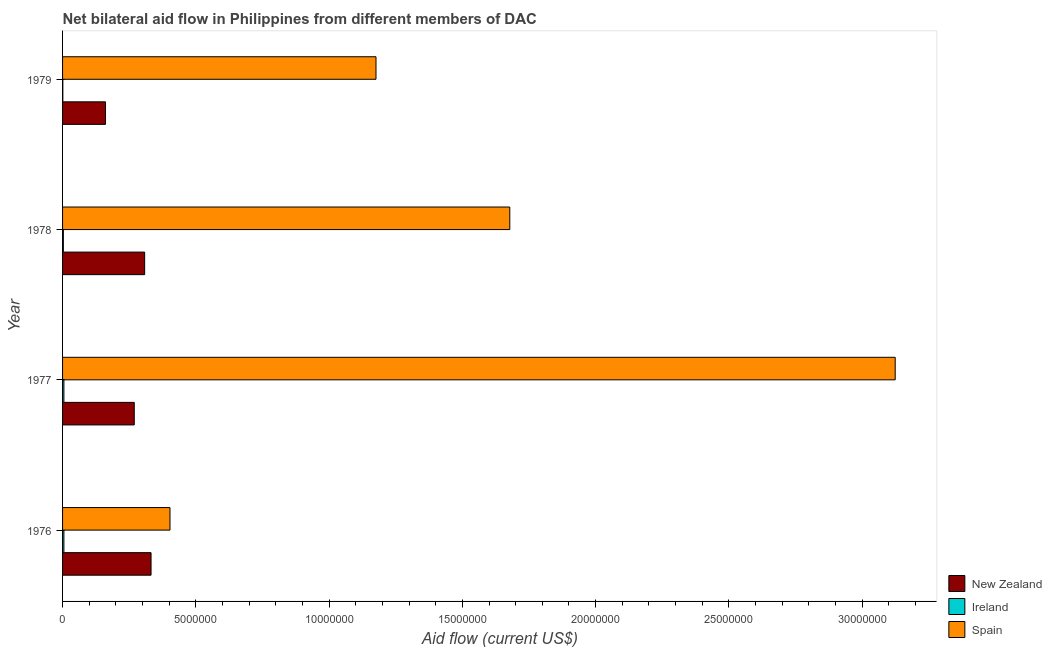How many different coloured bars are there?
Keep it short and to the point. 3. How many groups of bars are there?
Your response must be concise. 4. Are the number of bars per tick equal to the number of legend labels?
Ensure brevity in your answer.  Yes. Are the number of bars on each tick of the Y-axis equal?
Ensure brevity in your answer.  Yes. How many bars are there on the 1st tick from the top?
Make the answer very short. 3. How many bars are there on the 1st tick from the bottom?
Ensure brevity in your answer.  3. What is the label of the 4th group of bars from the top?
Give a very brief answer. 1976. What is the amount of aid provided by spain in 1978?
Keep it short and to the point. 1.68e+07. Across all years, what is the maximum amount of aid provided by spain?
Your response must be concise. 3.12e+07. Across all years, what is the minimum amount of aid provided by spain?
Your answer should be compact. 4.03e+06. In which year was the amount of aid provided by ireland maximum?
Ensure brevity in your answer.  1976. In which year was the amount of aid provided by spain minimum?
Offer a very short reply. 1976. What is the total amount of aid provided by spain in the graph?
Make the answer very short. 6.38e+07. What is the difference between the amount of aid provided by ireland in 1977 and that in 1979?
Give a very brief answer. 4.00e+04. What is the difference between the amount of aid provided by ireland in 1978 and the amount of aid provided by new zealand in 1977?
Offer a very short reply. -2.66e+06. What is the average amount of aid provided by new zealand per year?
Ensure brevity in your answer.  2.68e+06. In the year 1976, what is the difference between the amount of aid provided by spain and amount of aid provided by new zealand?
Provide a succinct answer. 7.10e+05. What is the ratio of the amount of aid provided by spain in 1978 to that in 1979?
Offer a very short reply. 1.43. Is the amount of aid provided by spain in 1976 less than that in 1979?
Provide a short and direct response. Yes. Is the difference between the amount of aid provided by ireland in 1976 and 1977 greater than the difference between the amount of aid provided by spain in 1976 and 1977?
Your answer should be compact. Yes. What is the difference between the highest and the second highest amount of aid provided by new zealand?
Provide a succinct answer. 2.40e+05. What is the difference between the highest and the lowest amount of aid provided by spain?
Make the answer very short. 2.72e+07. Is the sum of the amount of aid provided by spain in 1976 and 1978 greater than the maximum amount of aid provided by new zealand across all years?
Your response must be concise. Yes. What does the 2nd bar from the top in 1978 represents?
Offer a terse response. Ireland. What does the 1st bar from the bottom in 1978 represents?
Make the answer very short. New Zealand. How many bars are there?
Offer a terse response. 12. Are the values on the major ticks of X-axis written in scientific E-notation?
Your answer should be compact. No. Does the graph contain any zero values?
Keep it short and to the point. No. Does the graph contain grids?
Your response must be concise. No. How many legend labels are there?
Provide a succinct answer. 3. What is the title of the graph?
Your response must be concise. Net bilateral aid flow in Philippines from different members of DAC. Does "Czech Republic" appear as one of the legend labels in the graph?
Keep it short and to the point. No. What is the label or title of the Y-axis?
Make the answer very short. Year. What is the Aid flow (current US$) of New Zealand in 1976?
Your answer should be very brief. 3.32e+06. What is the Aid flow (current US$) of Ireland in 1976?
Make the answer very short. 5.00e+04. What is the Aid flow (current US$) of Spain in 1976?
Provide a short and direct response. 4.03e+06. What is the Aid flow (current US$) in New Zealand in 1977?
Offer a very short reply. 2.69e+06. What is the Aid flow (current US$) in Spain in 1977?
Provide a succinct answer. 3.12e+07. What is the Aid flow (current US$) of New Zealand in 1978?
Your response must be concise. 3.08e+06. What is the Aid flow (current US$) in Ireland in 1978?
Give a very brief answer. 3.00e+04. What is the Aid flow (current US$) in Spain in 1978?
Ensure brevity in your answer.  1.68e+07. What is the Aid flow (current US$) in New Zealand in 1979?
Your answer should be very brief. 1.61e+06. What is the Aid flow (current US$) of Spain in 1979?
Your answer should be compact. 1.18e+07. Across all years, what is the maximum Aid flow (current US$) in New Zealand?
Provide a succinct answer. 3.32e+06. Across all years, what is the maximum Aid flow (current US$) in Ireland?
Provide a succinct answer. 5.00e+04. Across all years, what is the maximum Aid flow (current US$) of Spain?
Give a very brief answer. 3.12e+07. Across all years, what is the minimum Aid flow (current US$) of New Zealand?
Your answer should be compact. 1.61e+06. Across all years, what is the minimum Aid flow (current US$) of Ireland?
Your response must be concise. 10000. Across all years, what is the minimum Aid flow (current US$) in Spain?
Ensure brevity in your answer.  4.03e+06. What is the total Aid flow (current US$) of New Zealand in the graph?
Offer a terse response. 1.07e+07. What is the total Aid flow (current US$) of Spain in the graph?
Keep it short and to the point. 6.38e+07. What is the difference between the Aid flow (current US$) of New Zealand in 1976 and that in 1977?
Your answer should be very brief. 6.30e+05. What is the difference between the Aid flow (current US$) in Ireland in 1976 and that in 1977?
Ensure brevity in your answer.  0. What is the difference between the Aid flow (current US$) in Spain in 1976 and that in 1977?
Your answer should be compact. -2.72e+07. What is the difference between the Aid flow (current US$) of New Zealand in 1976 and that in 1978?
Keep it short and to the point. 2.40e+05. What is the difference between the Aid flow (current US$) of Spain in 1976 and that in 1978?
Offer a very short reply. -1.28e+07. What is the difference between the Aid flow (current US$) of New Zealand in 1976 and that in 1979?
Provide a succinct answer. 1.71e+06. What is the difference between the Aid flow (current US$) of Ireland in 1976 and that in 1979?
Keep it short and to the point. 4.00e+04. What is the difference between the Aid flow (current US$) in Spain in 1976 and that in 1979?
Your answer should be very brief. -7.73e+06. What is the difference between the Aid flow (current US$) of New Zealand in 1977 and that in 1978?
Your answer should be compact. -3.90e+05. What is the difference between the Aid flow (current US$) in Ireland in 1977 and that in 1978?
Give a very brief answer. 2.00e+04. What is the difference between the Aid flow (current US$) in Spain in 1977 and that in 1978?
Keep it short and to the point. 1.45e+07. What is the difference between the Aid flow (current US$) in New Zealand in 1977 and that in 1979?
Provide a succinct answer. 1.08e+06. What is the difference between the Aid flow (current US$) of Spain in 1977 and that in 1979?
Provide a succinct answer. 1.95e+07. What is the difference between the Aid flow (current US$) of New Zealand in 1978 and that in 1979?
Your answer should be compact. 1.47e+06. What is the difference between the Aid flow (current US$) in Ireland in 1978 and that in 1979?
Offer a terse response. 2.00e+04. What is the difference between the Aid flow (current US$) of Spain in 1978 and that in 1979?
Offer a very short reply. 5.02e+06. What is the difference between the Aid flow (current US$) in New Zealand in 1976 and the Aid flow (current US$) in Ireland in 1977?
Keep it short and to the point. 3.27e+06. What is the difference between the Aid flow (current US$) of New Zealand in 1976 and the Aid flow (current US$) of Spain in 1977?
Make the answer very short. -2.79e+07. What is the difference between the Aid flow (current US$) in Ireland in 1976 and the Aid flow (current US$) in Spain in 1977?
Make the answer very short. -3.12e+07. What is the difference between the Aid flow (current US$) in New Zealand in 1976 and the Aid flow (current US$) in Ireland in 1978?
Provide a short and direct response. 3.29e+06. What is the difference between the Aid flow (current US$) in New Zealand in 1976 and the Aid flow (current US$) in Spain in 1978?
Offer a terse response. -1.35e+07. What is the difference between the Aid flow (current US$) in Ireland in 1976 and the Aid flow (current US$) in Spain in 1978?
Your answer should be very brief. -1.67e+07. What is the difference between the Aid flow (current US$) in New Zealand in 1976 and the Aid flow (current US$) in Ireland in 1979?
Keep it short and to the point. 3.31e+06. What is the difference between the Aid flow (current US$) of New Zealand in 1976 and the Aid flow (current US$) of Spain in 1979?
Your response must be concise. -8.44e+06. What is the difference between the Aid flow (current US$) of Ireland in 1976 and the Aid flow (current US$) of Spain in 1979?
Your answer should be very brief. -1.17e+07. What is the difference between the Aid flow (current US$) of New Zealand in 1977 and the Aid flow (current US$) of Ireland in 1978?
Your answer should be very brief. 2.66e+06. What is the difference between the Aid flow (current US$) in New Zealand in 1977 and the Aid flow (current US$) in Spain in 1978?
Keep it short and to the point. -1.41e+07. What is the difference between the Aid flow (current US$) in Ireland in 1977 and the Aid flow (current US$) in Spain in 1978?
Offer a very short reply. -1.67e+07. What is the difference between the Aid flow (current US$) of New Zealand in 1977 and the Aid flow (current US$) of Ireland in 1979?
Ensure brevity in your answer.  2.68e+06. What is the difference between the Aid flow (current US$) of New Zealand in 1977 and the Aid flow (current US$) of Spain in 1979?
Your answer should be compact. -9.07e+06. What is the difference between the Aid flow (current US$) of Ireland in 1977 and the Aid flow (current US$) of Spain in 1979?
Provide a short and direct response. -1.17e+07. What is the difference between the Aid flow (current US$) in New Zealand in 1978 and the Aid flow (current US$) in Ireland in 1979?
Make the answer very short. 3.07e+06. What is the difference between the Aid flow (current US$) in New Zealand in 1978 and the Aid flow (current US$) in Spain in 1979?
Ensure brevity in your answer.  -8.68e+06. What is the difference between the Aid flow (current US$) of Ireland in 1978 and the Aid flow (current US$) of Spain in 1979?
Keep it short and to the point. -1.17e+07. What is the average Aid flow (current US$) in New Zealand per year?
Your answer should be compact. 2.68e+06. What is the average Aid flow (current US$) in Ireland per year?
Your answer should be very brief. 3.50e+04. What is the average Aid flow (current US$) in Spain per year?
Provide a succinct answer. 1.60e+07. In the year 1976, what is the difference between the Aid flow (current US$) of New Zealand and Aid flow (current US$) of Ireland?
Provide a succinct answer. 3.27e+06. In the year 1976, what is the difference between the Aid flow (current US$) of New Zealand and Aid flow (current US$) of Spain?
Ensure brevity in your answer.  -7.10e+05. In the year 1976, what is the difference between the Aid flow (current US$) of Ireland and Aid flow (current US$) of Spain?
Your answer should be compact. -3.98e+06. In the year 1977, what is the difference between the Aid flow (current US$) in New Zealand and Aid flow (current US$) in Ireland?
Offer a terse response. 2.64e+06. In the year 1977, what is the difference between the Aid flow (current US$) in New Zealand and Aid flow (current US$) in Spain?
Ensure brevity in your answer.  -2.86e+07. In the year 1977, what is the difference between the Aid flow (current US$) of Ireland and Aid flow (current US$) of Spain?
Ensure brevity in your answer.  -3.12e+07. In the year 1978, what is the difference between the Aid flow (current US$) in New Zealand and Aid flow (current US$) in Ireland?
Your response must be concise. 3.05e+06. In the year 1978, what is the difference between the Aid flow (current US$) in New Zealand and Aid flow (current US$) in Spain?
Ensure brevity in your answer.  -1.37e+07. In the year 1978, what is the difference between the Aid flow (current US$) in Ireland and Aid flow (current US$) in Spain?
Your answer should be compact. -1.68e+07. In the year 1979, what is the difference between the Aid flow (current US$) in New Zealand and Aid flow (current US$) in Ireland?
Offer a terse response. 1.60e+06. In the year 1979, what is the difference between the Aid flow (current US$) of New Zealand and Aid flow (current US$) of Spain?
Make the answer very short. -1.02e+07. In the year 1979, what is the difference between the Aid flow (current US$) of Ireland and Aid flow (current US$) of Spain?
Keep it short and to the point. -1.18e+07. What is the ratio of the Aid flow (current US$) in New Zealand in 1976 to that in 1977?
Provide a short and direct response. 1.23. What is the ratio of the Aid flow (current US$) in Spain in 1976 to that in 1977?
Your answer should be very brief. 0.13. What is the ratio of the Aid flow (current US$) in New Zealand in 1976 to that in 1978?
Give a very brief answer. 1.08. What is the ratio of the Aid flow (current US$) of Ireland in 1976 to that in 1978?
Keep it short and to the point. 1.67. What is the ratio of the Aid flow (current US$) in Spain in 1976 to that in 1978?
Give a very brief answer. 0.24. What is the ratio of the Aid flow (current US$) of New Zealand in 1976 to that in 1979?
Your response must be concise. 2.06. What is the ratio of the Aid flow (current US$) in Spain in 1976 to that in 1979?
Offer a terse response. 0.34. What is the ratio of the Aid flow (current US$) in New Zealand in 1977 to that in 1978?
Offer a very short reply. 0.87. What is the ratio of the Aid flow (current US$) of Ireland in 1977 to that in 1978?
Your answer should be very brief. 1.67. What is the ratio of the Aid flow (current US$) in Spain in 1977 to that in 1978?
Keep it short and to the point. 1.86. What is the ratio of the Aid flow (current US$) in New Zealand in 1977 to that in 1979?
Offer a terse response. 1.67. What is the ratio of the Aid flow (current US$) in Ireland in 1977 to that in 1979?
Make the answer very short. 5. What is the ratio of the Aid flow (current US$) in Spain in 1977 to that in 1979?
Provide a succinct answer. 2.66. What is the ratio of the Aid flow (current US$) of New Zealand in 1978 to that in 1979?
Keep it short and to the point. 1.91. What is the ratio of the Aid flow (current US$) of Ireland in 1978 to that in 1979?
Provide a succinct answer. 3. What is the ratio of the Aid flow (current US$) in Spain in 1978 to that in 1979?
Your response must be concise. 1.43. What is the difference between the highest and the second highest Aid flow (current US$) in New Zealand?
Your answer should be very brief. 2.40e+05. What is the difference between the highest and the second highest Aid flow (current US$) in Spain?
Ensure brevity in your answer.  1.45e+07. What is the difference between the highest and the lowest Aid flow (current US$) in New Zealand?
Keep it short and to the point. 1.71e+06. What is the difference between the highest and the lowest Aid flow (current US$) of Spain?
Provide a succinct answer. 2.72e+07. 